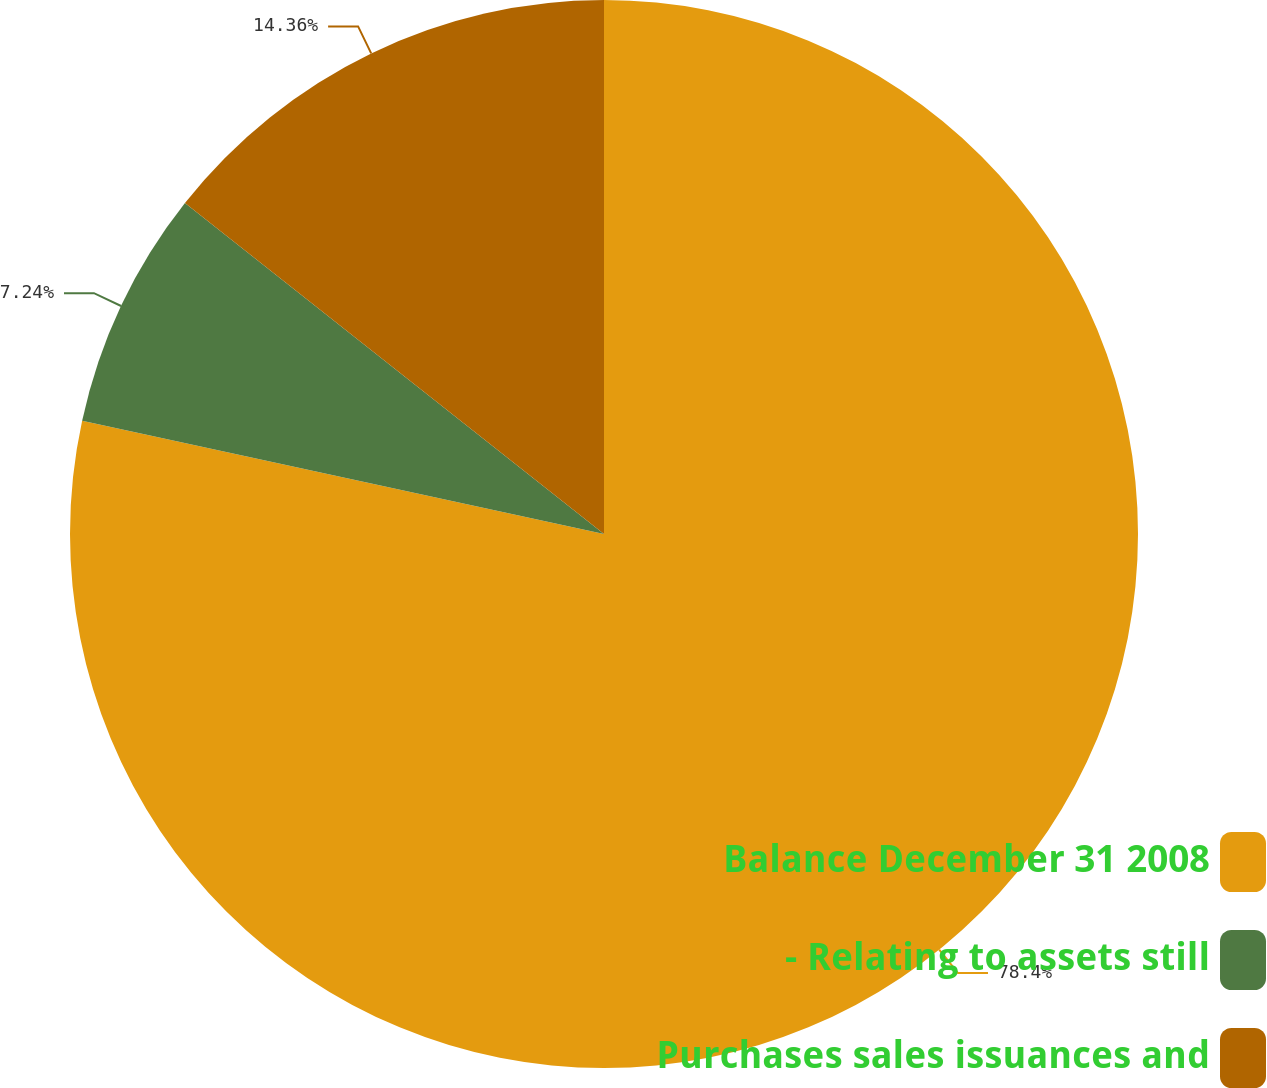<chart> <loc_0><loc_0><loc_500><loc_500><pie_chart><fcel>Balance December 31 2008<fcel>- Relating to assets still<fcel>Purchases sales issuances and<nl><fcel>78.4%<fcel>7.24%<fcel>14.36%<nl></chart> 